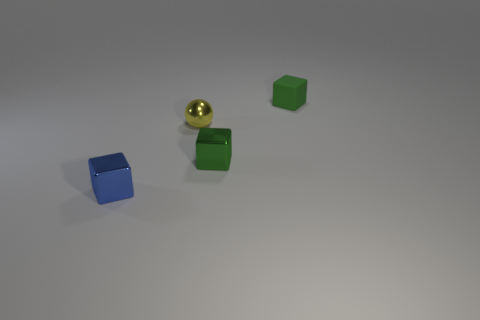Subtract all cyan blocks. Subtract all cyan balls. How many blocks are left? 3 Add 4 brown cylinders. How many objects exist? 8 Subtract all balls. How many objects are left? 3 Subtract all yellow metallic balls. Subtract all tiny matte cubes. How many objects are left? 2 Add 3 yellow metallic balls. How many yellow metallic balls are left? 4 Add 4 shiny things. How many shiny things exist? 7 Subtract 0 red cylinders. How many objects are left? 4 